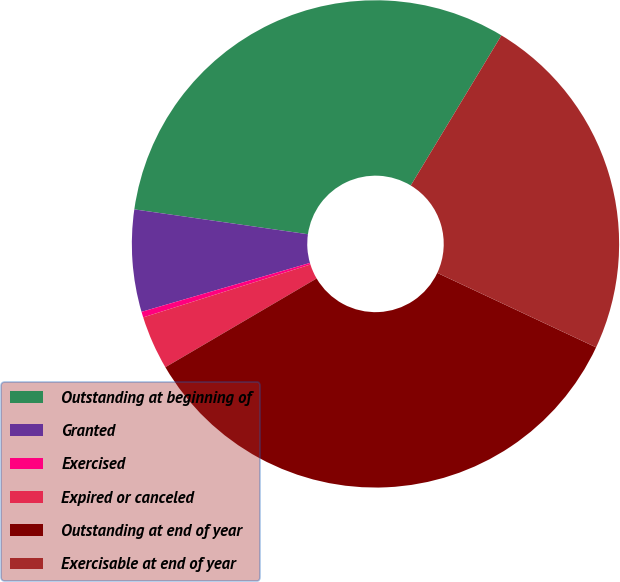Convert chart. <chart><loc_0><loc_0><loc_500><loc_500><pie_chart><fcel>Outstanding at beginning of<fcel>Granted<fcel>Exercised<fcel>Expired or canceled<fcel>Outstanding at end of year<fcel>Exercisable at end of year<nl><fcel>31.38%<fcel>6.76%<fcel>0.38%<fcel>3.57%<fcel>34.57%<fcel>23.33%<nl></chart> 